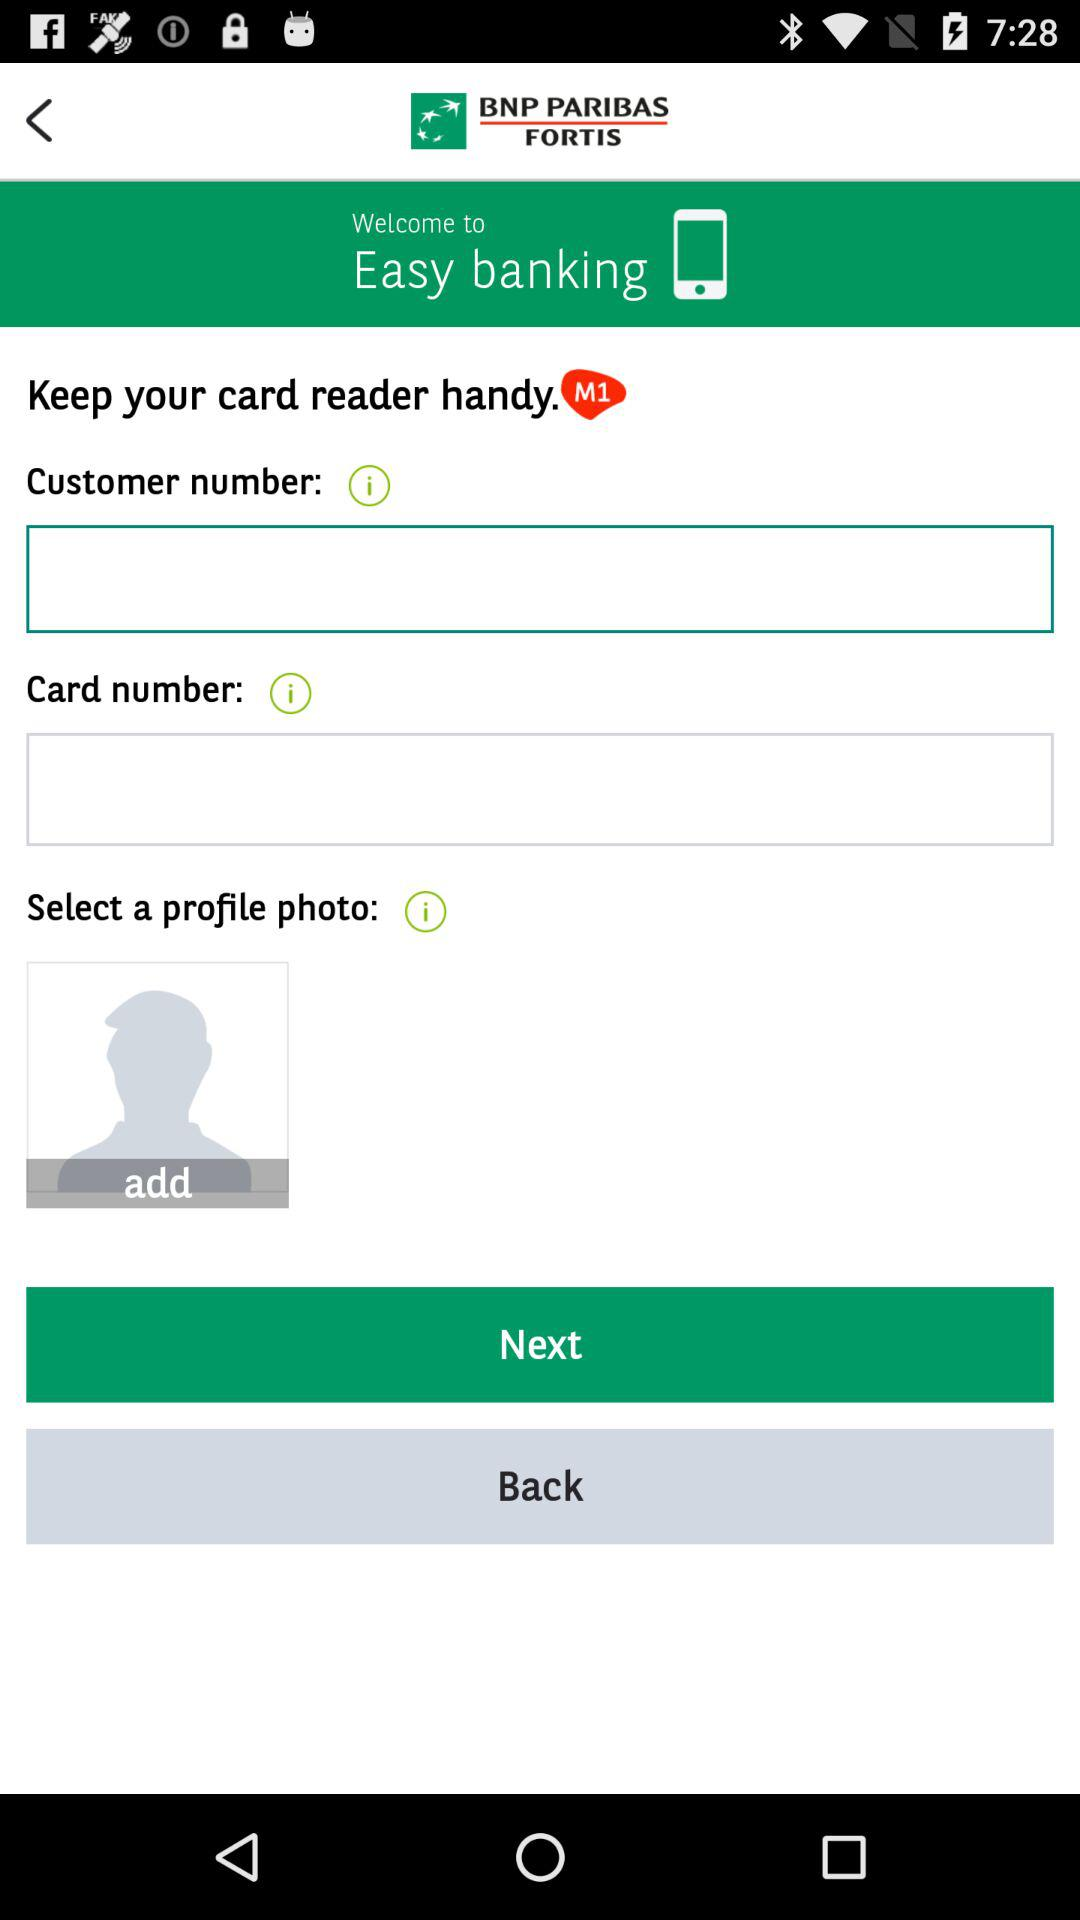What is the app name? The app name is "Easy banking". 